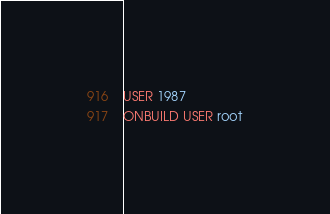<code> <loc_0><loc_0><loc_500><loc_500><_Dockerfile_>
USER 1987
ONBUILD USER root
</code> 